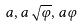Convert formula to latex. <formula><loc_0><loc_0><loc_500><loc_500>a , a \sqrt { \varphi } , a \varphi</formula> 